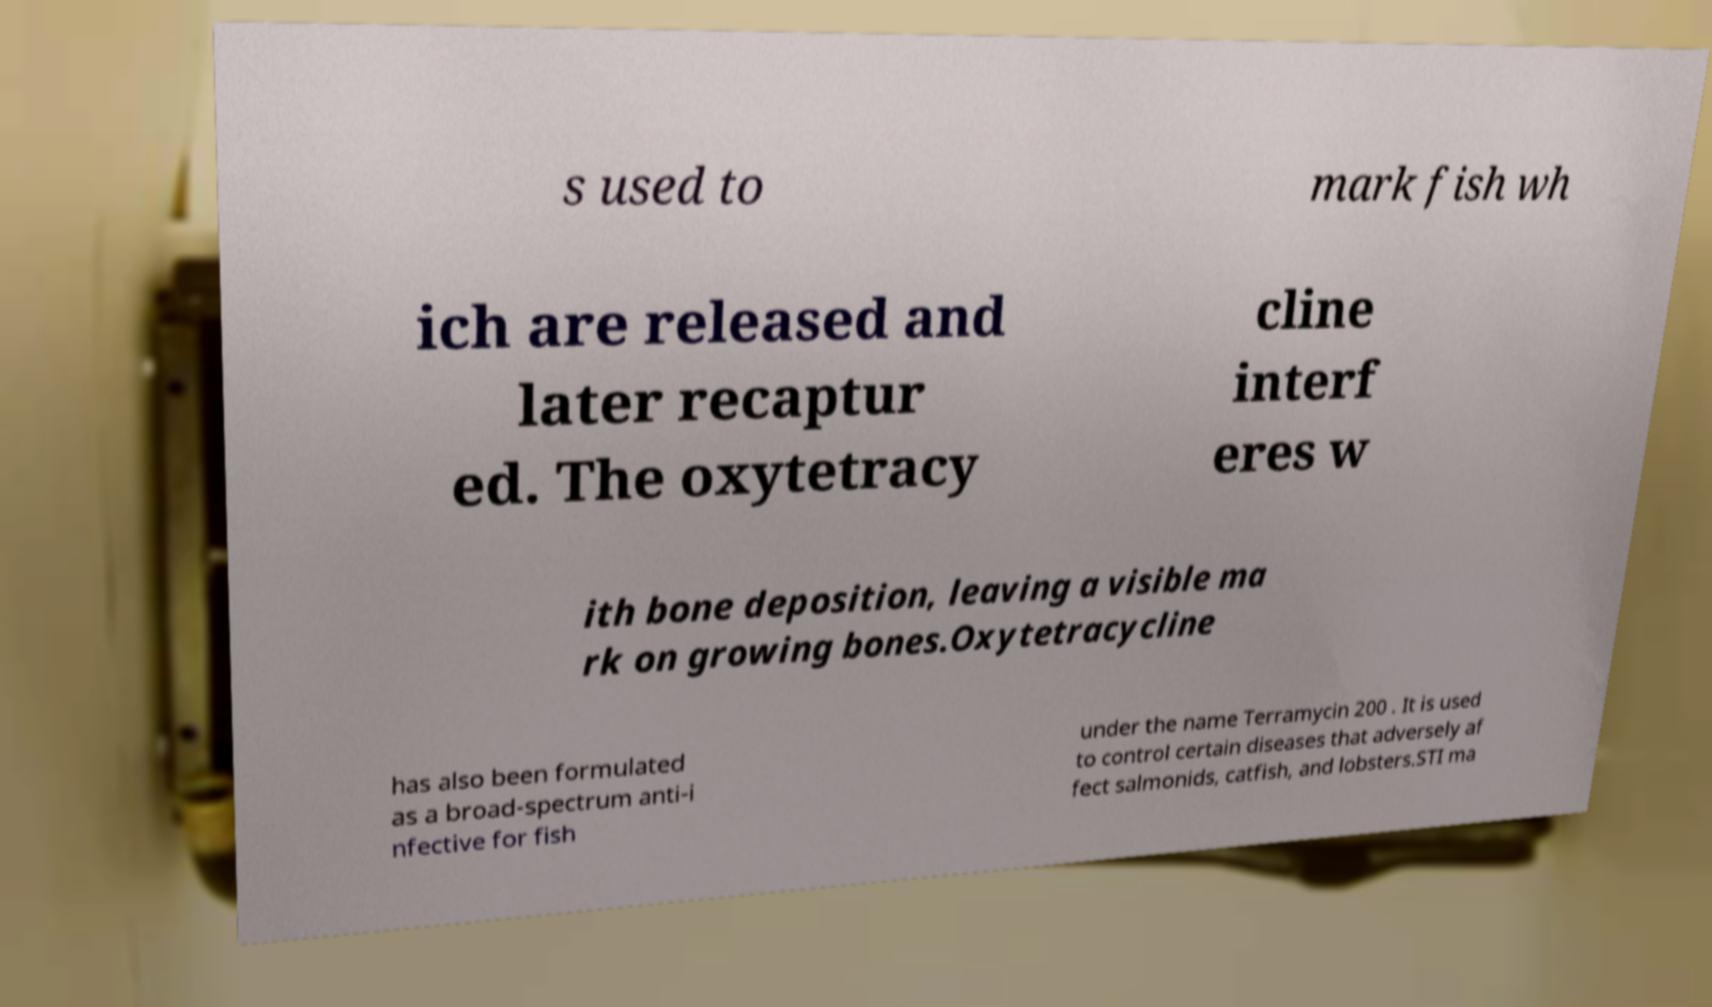Can you read and provide the text displayed in the image?This photo seems to have some interesting text. Can you extract and type it out for me? s used to mark fish wh ich are released and later recaptur ed. The oxytetracy cline interf eres w ith bone deposition, leaving a visible ma rk on growing bones.Oxytetracycline has also been formulated as a broad-spectrum anti-i nfective for fish under the name Terramycin 200 . It is used to control certain diseases that adversely af fect salmonids, catfish, and lobsters.STI ma 